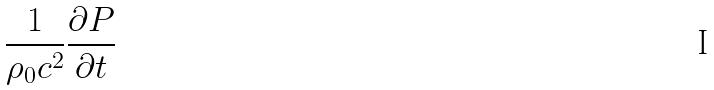Convert formula to latex. <formula><loc_0><loc_0><loc_500><loc_500>\frac { 1 } { \rho _ { 0 } c ^ { 2 } } \frac { \partial P } { \partial t }</formula> 